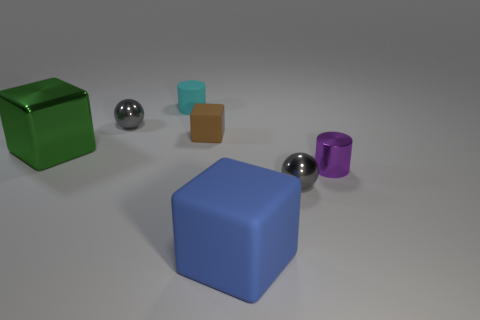How many tiny brown matte things are there?
Ensure brevity in your answer.  1. Do the brown matte cube and the green block have the same size?
Your response must be concise. No. What number of other objects are the same shape as the cyan rubber thing?
Your response must be concise. 1. There is a gray ball that is behind the ball to the right of the brown rubber object; what is its material?
Provide a short and direct response. Metal. Are there any big things right of the brown cube?
Your answer should be compact. Yes. Do the green object and the blue thing that is in front of the green metallic block have the same size?
Your answer should be compact. Yes. There is a green thing that is the same shape as the small brown matte thing; what size is it?
Your answer should be compact. Large. There is a rubber thing to the right of the small brown rubber thing; is its size the same as the gray shiny ball right of the large blue rubber object?
Provide a short and direct response. No. How many tiny objects are rubber cylinders or shiny blocks?
Your response must be concise. 1. How many cubes are in front of the big green thing and left of the big blue rubber block?
Your answer should be very brief. 0. 